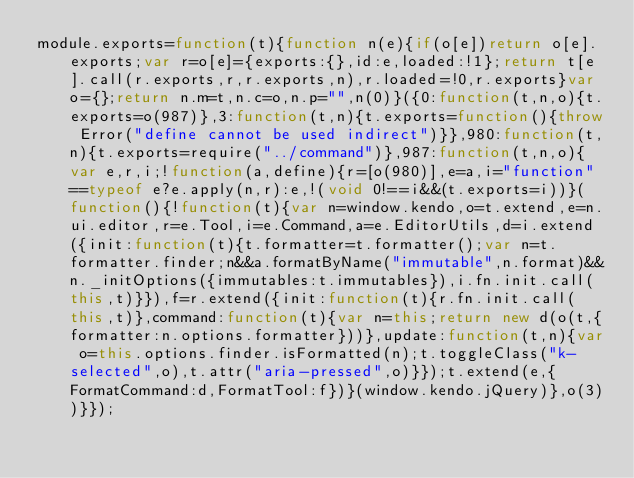<code> <loc_0><loc_0><loc_500><loc_500><_JavaScript_>module.exports=function(t){function n(e){if(o[e])return o[e].exports;var r=o[e]={exports:{},id:e,loaded:!1};return t[e].call(r.exports,r,r.exports,n),r.loaded=!0,r.exports}var o={};return n.m=t,n.c=o,n.p="",n(0)}({0:function(t,n,o){t.exports=o(987)},3:function(t,n){t.exports=function(){throw Error("define cannot be used indirect")}},980:function(t,n){t.exports=require("../command")},987:function(t,n,o){var e,r,i;!function(a,define){r=[o(980)],e=a,i="function"==typeof e?e.apply(n,r):e,!(void 0!==i&&(t.exports=i))}(function(){!function(t){var n=window.kendo,o=t.extend,e=n.ui.editor,r=e.Tool,i=e.Command,a=e.EditorUtils,d=i.extend({init:function(t){t.formatter=t.formatter();var n=t.formatter.finder;n&&a.formatByName("immutable",n.format)&&n._initOptions({immutables:t.immutables}),i.fn.init.call(this,t)}}),f=r.extend({init:function(t){r.fn.init.call(this,t)},command:function(t){var n=this;return new d(o(t,{formatter:n.options.formatter}))},update:function(t,n){var o=this.options.finder.isFormatted(n);t.toggleClass("k-selected",o),t.attr("aria-pressed",o)}});t.extend(e,{FormatCommand:d,FormatTool:f})}(window.kendo.jQuery)},o(3))}});</code> 